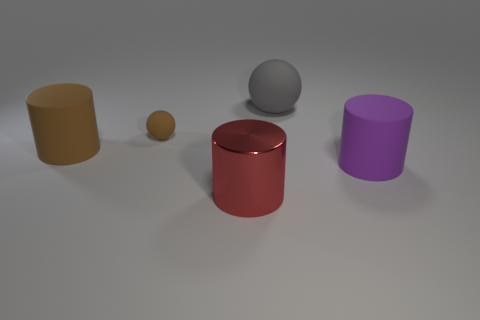Add 2 big green shiny cubes. How many objects exist? 7 Subtract all spheres. How many objects are left? 3 Add 4 big red cylinders. How many big red cylinders exist? 5 Subtract 0 red balls. How many objects are left? 5 Subtract all green shiny balls. Subtract all large brown matte cylinders. How many objects are left? 4 Add 4 metal cylinders. How many metal cylinders are left? 5 